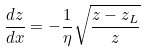<formula> <loc_0><loc_0><loc_500><loc_500>\frac { d z } { d x } = - \frac { 1 } { \eta } \sqrt { \frac { z - z _ { L } } { z } }</formula> 